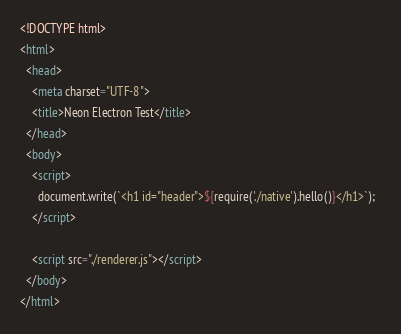<code> <loc_0><loc_0><loc_500><loc_500><_HTML_><!DOCTYPE html>
<html>
  <head>
    <meta charset="UTF-8">
    <title>Neon Electron Test</title>
  </head>
  <body>
    <script>
      document.write(`<h1 id="header">${require('./native').hello()}</h1>`);  
    </script>  

    <script src="./renderer.js"></script>
  </body>
</html>
</code> 